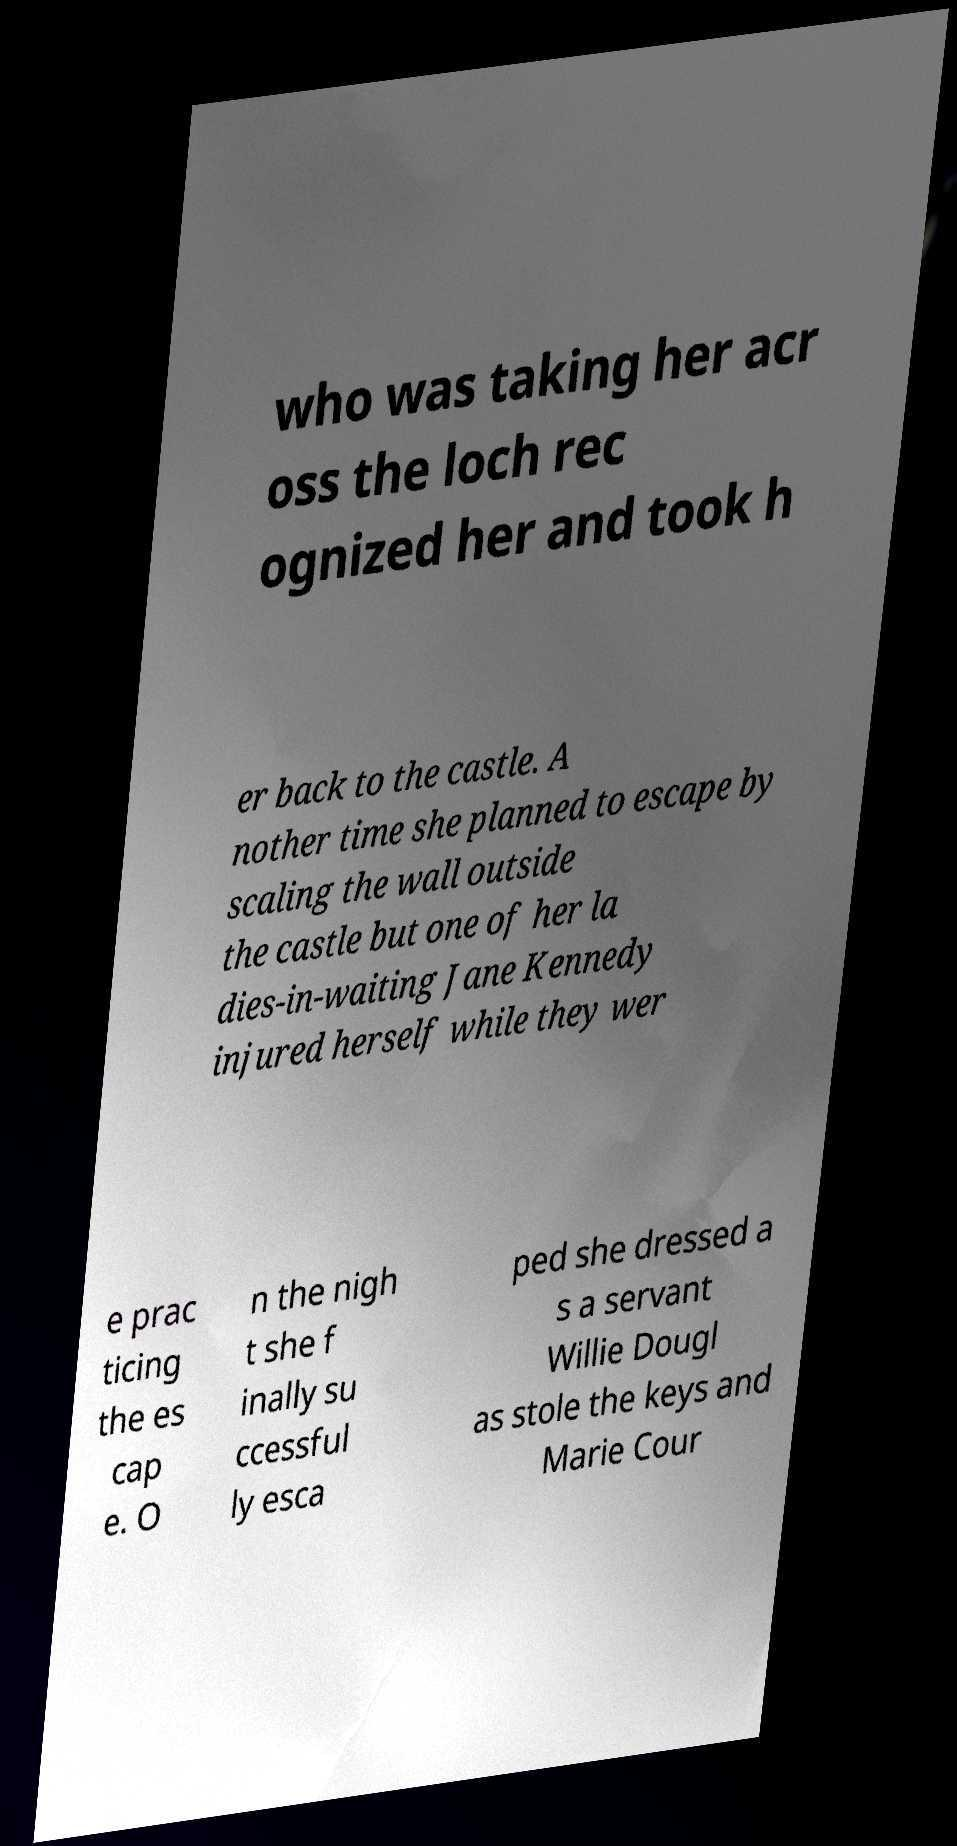Can you read and provide the text displayed in the image?This photo seems to have some interesting text. Can you extract and type it out for me? who was taking her acr oss the loch rec ognized her and took h er back to the castle. A nother time she planned to escape by scaling the wall outside the castle but one of her la dies-in-waiting Jane Kennedy injured herself while they wer e prac ticing the es cap e. O n the nigh t she f inally su ccessful ly esca ped she dressed a s a servant Willie Dougl as stole the keys and Marie Cour 